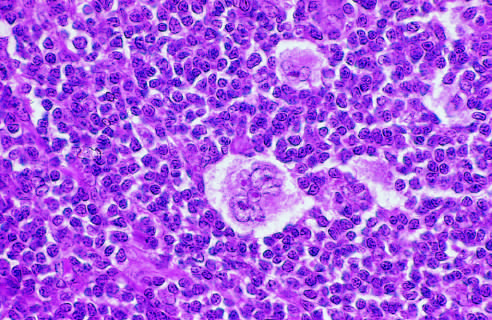s a distinctive lacunar cell with a multilobed nucleus containing many small nucleoli seen lying within a clear space created by retraction of its cytoplasms?
Answer the question using a single word or phrase. Yes 